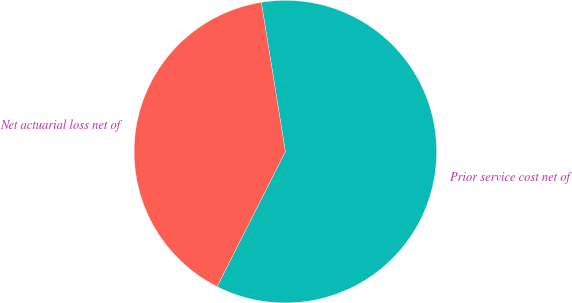Convert chart to OTSL. <chart><loc_0><loc_0><loc_500><loc_500><pie_chart><fcel>Prior service cost net of<fcel>Net actuarial loss net of<nl><fcel>60.0%<fcel>40.0%<nl></chart> 